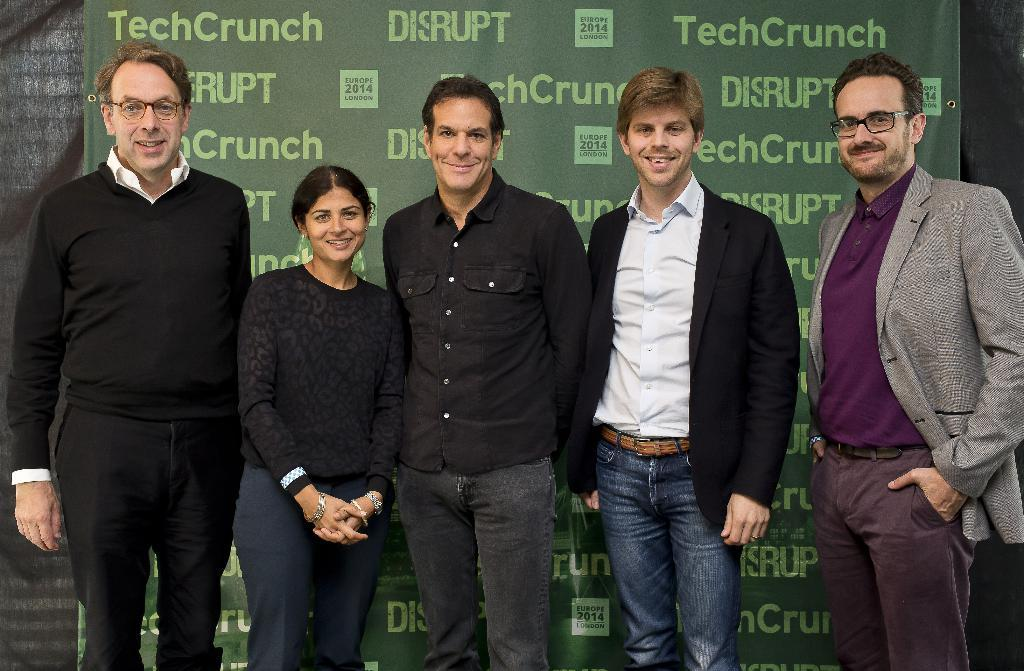What is happening in the foreground of the image? There is a group of people in the foreground of the image. What are the people doing? The people are standing. What can be seen in the background of the image? There is a banner and a curtain in the background of the image. What type of cherry is being used to decorate the banner in the image? There is no cherry present in the image, and therefore no such decoration can be observed. 